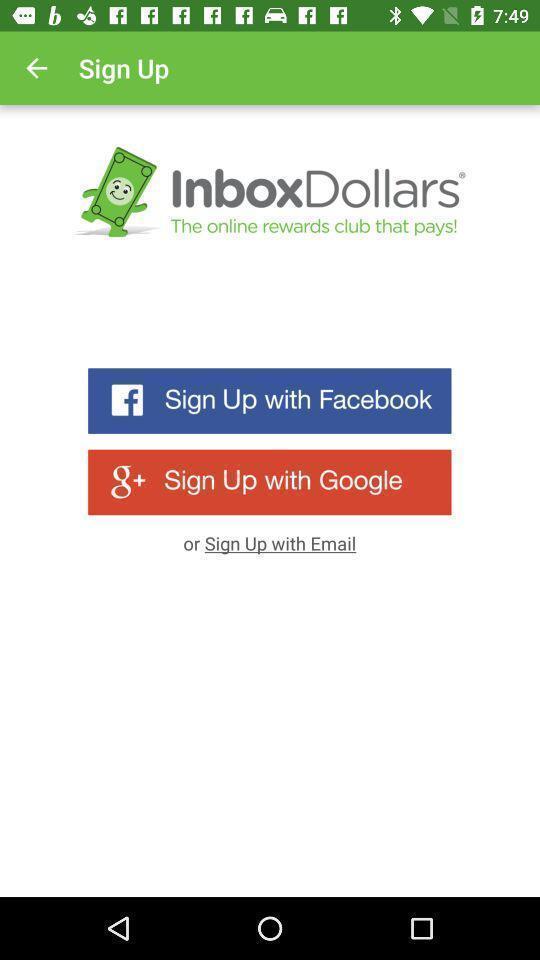Tell me what you see in this picture. Welcome page of a payment app. 